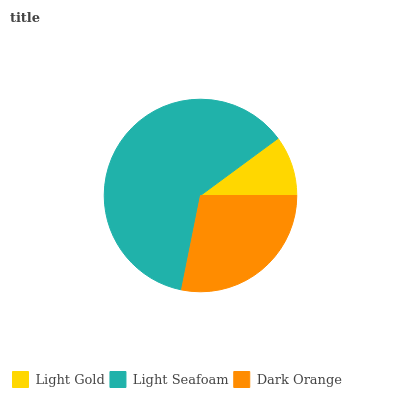Is Light Gold the minimum?
Answer yes or no. Yes. Is Light Seafoam the maximum?
Answer yes or no. Yes. Is Dark Orange the minimum?
Answer yes or no. No. Is Dark Orange the maximum?
Answer yes or no. No. Is Light Seafoam greater than Dark Orange?
Answer yes or no. Yes. Is Dark Orange less than Light Seafoam?
Answer yes or no. Yes. Is Dark Orange greater than Light Seafoam?
Answer yes or no. No. Is Light Seafoam less than Dark Orange?
Answer yes or no. No. Is Dark Orange the high median?
Answer yes or no. Yes. Is Dark Orange the low median?
Answer yes or no. Yes. Is Light Gold the high median?
Answer yes or no. No. Is Light Seafoam the low median?
Answer yes or no. No. 